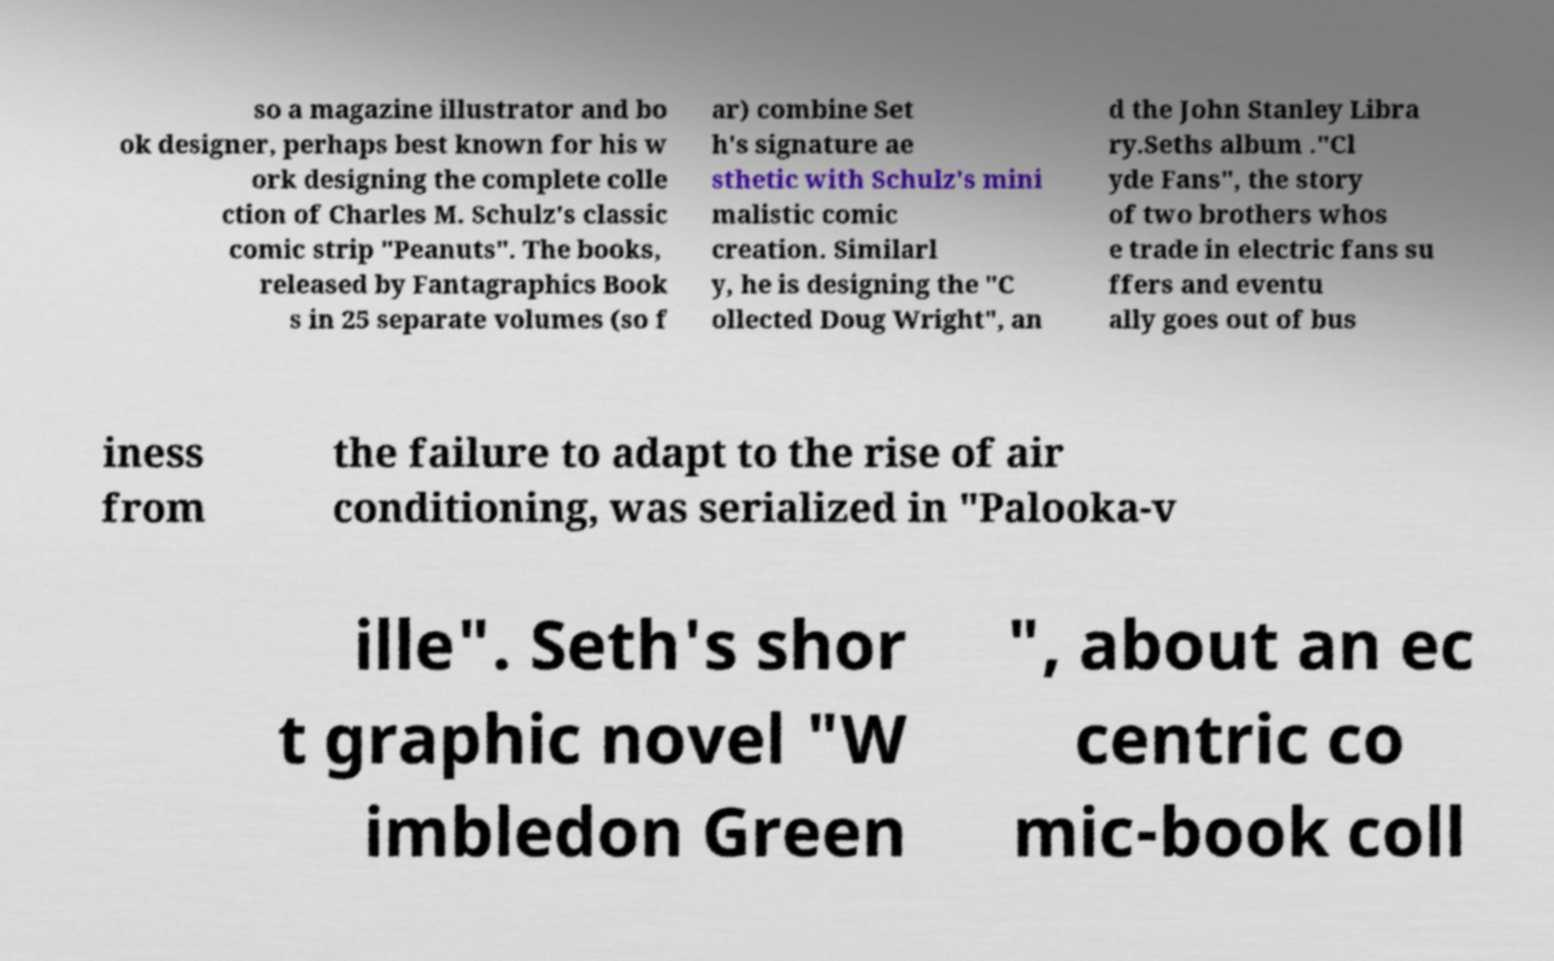Could you assist in decoding the text presented in this image and type it out clearly? so a magazine illustrator and bo ok designer, perhaps best known for his w ork designing the complete colle ction of Charles M. Schulz's classic comic strip "Peanuts". The books, released by Fantagraphics Book s in 25 separate volumes (so f ar) combine Set h's signature ae sthetic with Schulz's mini malistic comic creation. Similarl y, he is designing the "C ollected Doug Wright", an d the John Stanley Libra ry.Seths album ."Cl yde Fans", the story of two brothers whos e trade in electric fans su ffers and eventu ally goes out of bus iness from the failure to adapt to the rise of air conditioning, was serialized in "Palooka-v ille". Seth's shor t graphic novel "W imbledon Green ", about an ec centric co mic-book coll 